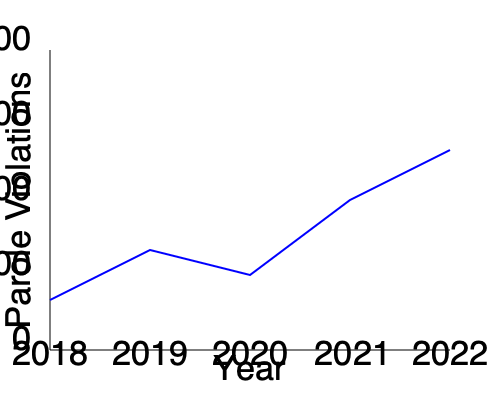As a neighborhood watch captain concerned about the effectiveness of parole, how would you interpret the trend in parole violations from 2018 to 2022, and what might this suggest about the parole system's performance? To interpret the trend in parole violations from 2018 to 2022:

1. Observe the starting point: In 2018, the number of parole violations is relatively high.

2. Analyze the trend from 2018 to 2019:
   - There's a noticeable decrease in violations.
   - This could indicate initial improvements in the parole system or supervision methods.

3. Examine the slight increase from 2019 to 2020:
   - This minor uptick might be attributed to external factors (e.g., the COVID-19 pandemic) affecting parolees' ability to comply with conditions.

4. Note the significant decrease from 2020 to 2021:
   - This sharp decline suggests potentially effective interventions or policy changes.

5. Observe the continued decrease from 2021 to 2022:
   - The downward trend persists, indicating sustained improvement.

6. Overall trend analysis:
   - The general trend from 2018 to 2022 is downward, despite a small increase in 2020.
   - This suggests an overall improvement in the parole system's effectiveness.

7. Implications for the parole system's performance:
   - The declining number of violations could indicate:
     a) More effective supervision and support for parolees
     b) Improved rehabilitation programs
     c) Better selection criteria for granting parole
   - However, it's important to consider other factors that might influence this trend, such as changes in reporting methods or alterations in parole conditions.

8. Considerations for a skeptical neighborhood watch captain:
   - While the trend is positive, it's crucial to examine the nature and severity of the remaining violations.
   - The effectiveness of the parole system should also be measured by recidivism rates and successful reintegration of parolees into society, not just by the number of violations.
Answer: The downward trend in parole violations from 2018 to 2022 suggests improving effectiveness of the parole system, but further investigation into the nature of remaining violations and overall recidivism rates is needed for a comprehensive assessment. 